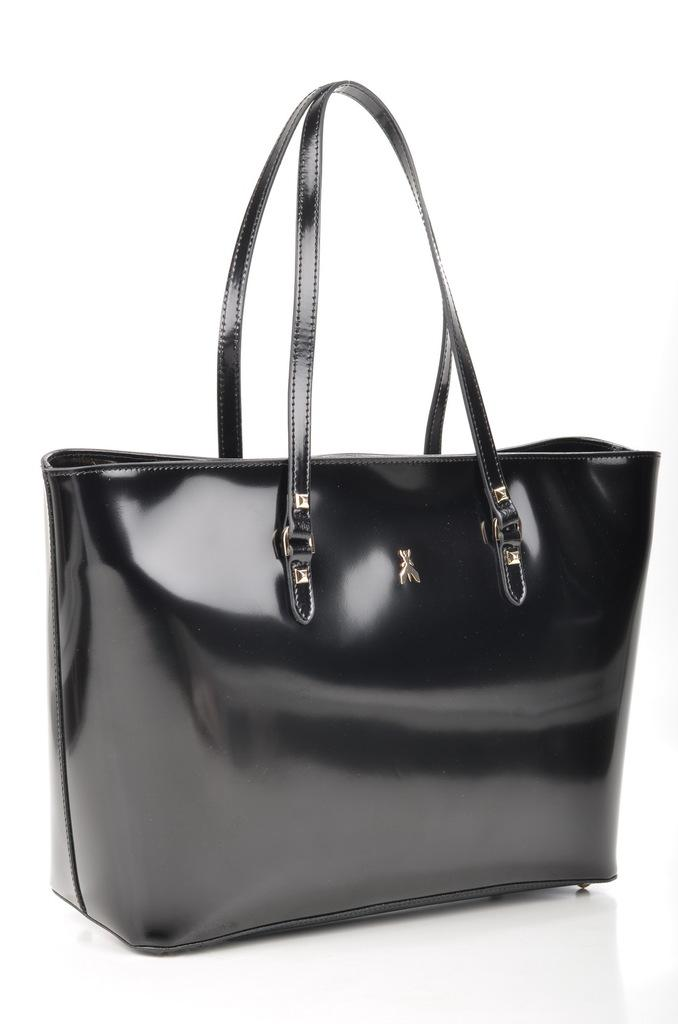What type of handbag is in the picture? There is a black handbag in the picture. What material is used for the jointers of the handbag? The handbag has steel jointers. What can be found inside the handbag? There is a silver-colored object placed in the handbag. How many kittens are playing with the lipstick in the handbag? There are no kittens or lipstick present in the image. What time is it according to the watch inside the handbag? There is no watch mentioned in the image, so we cannot determine the time. 